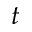<formula> <loc_0><loc_0><loc_500><loc_500>t</formula> 